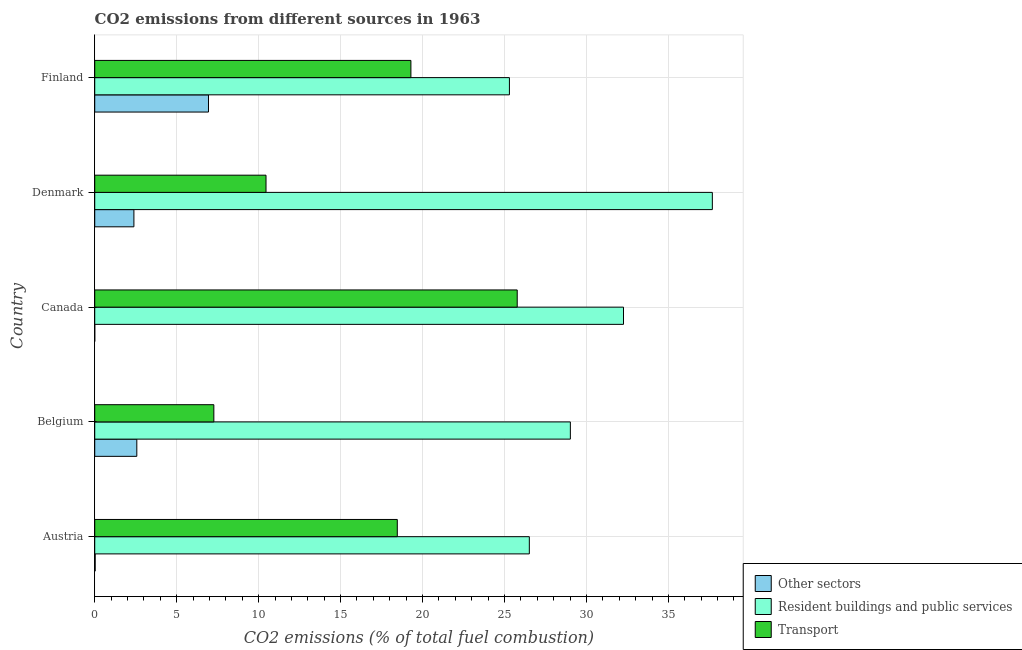How many different coloured bars are there?
Your response must be concise. 3. How many groups of bars are there?
Offer a very short reply. 5. Are the number of bars per tick equal to the number of legend labels?
Keep it short and to the point. No. Are the number of bars on each tick of the Y-axis equal?
Your answer should be very brief. No. How many bars are there on the 2nd tick from the top?
Your answer should be compact. 3. What is the label of the 2nd group of bars from the top?
Your answer should be very brief. Denmark. In how many cases, is the number of bars for a given country not equal to the number of legend labels?
Your answer should be very brief. 1. What is the percentage of co2 emissions from resident buildings and public services in Belgium?
Your response must be concise. 29.02. Across all countries, what is the maximum percentage of co2 emissions from resident buildings and public services?
Your answer should be compact. 37.68. What is the total percentage of co2 emissions from resident buildings and public services in the graph?
Provide a short and direct response. 150.78. What is the difference between the percentage of co2 emissions from resident buildings and public services in Austria and that in Belgium?
Provide a short and direct response. -2.5. What is the difference between the percentage of co2 emissions from resident buildings and public services in Finland and the percentage of co2 emissions from transport in Canada?
Your answer should be very brief. -0.48. What is the average percentage of co2 emissions from transport per country?
Provide a succinct answer. 16.25. What is the difference between the percentage of co2 emissions from other sectors and percentage of co2 emissions from resident buildings and public services in Denmark?
Offer a very short reply. -35.29. What is the ratio of the percentage of co2 emissions from resident buildings and public services in Canada to that in Finland?
Make the answer very short. 1.27. What is the difference between the highest and the second highest percentage of co2 emissions from resident buildings and public services?
Keep it short and to the point. 5.42. What is the difference between the highest and the lowest percentage of co2 emissions from transport?
Give a very brief answer. 18.51. How many bars are there?
Make the answer very short. 14. Are all the bars in the graph horizontal?
Give a very brief answer. Yes. How many countries are there in the graph?
Provide a succinct answer. 5. What is the title of the graph?
Offer a very short reply. CO2 emissions from different sources in 1963. What is the label or title of the X-axis?
Ensure brevity in your answer.  CO2 emissions (% of total fuel combustion). What is the CO2 emissions (% of total fuel combustion) of Other sectors in Austria?
Keep it short and to the point. 0.03. What is the CO2 emissions (% of total fuel combustion) of Resident buildings and public services in Austria?
Provide a succinct answer. 26.52. What is the CO2 emissions (% of total fuel combustion) in Transport in Austria?
Offer a very short reply. 18.46. What is the CO2 emissions (% of total fuel combustion) of Other sectors in Belgium?
Provide a short and direct response. 2.57. What is the CO2 emissions (% of total fuel combustion) in Resident buildings and public services in Belgium?
Provide a short and direct response. 29.02. What is the CO2 emissions (% of total fuel combustion) of Transport in Belgium?
Give a very brief answer. 7.27. What is the CO2 emissions (% of total fuel combustion) in Resident buildings and public services in Canada?
Your response must be concise. 32.26. What is the CO2 emissions (% of total fuel combustion) of Transport in Canada?
Offer a terse response. 25.78. What is the CO2 emissions (% of total fuel combustion) in Other sectors in Denmark?
Make the answer very short. 2.39. What is the CO2 emissions (% of total fuel combustion) in Resident buildings and public services in Denmark?
Keep it short and to the point. 37.68. What is the CO2 emissions (% of total fuel combustion) in Transport in Denmark?
Your answer should be very brief. 10.45. What is the CO2 emissions (% of total fuel combustion) of Other sectors in Finland?
Provide a short and direct response. 6.94. What is the CO2 emissions (% of total fuel combustion) of Resident buildings and public services in Finland?
Ensure brevity in your answer.  25.3. What is the CO2 emissions (% of total fuel combustion) of Transport in Finland?
Provide a succinct answer. 19.29. Across all countries, what is the maximum CO2 emissions (% of total fuel combustion) of Other sectors?
Provide a short and direct response. 6.94. Across all countries, what is the maximum CO2 emissions (% of total fuel combustion) of Resident buildings and public services?
Provide a succinct answer. 37.68. Across all countries, what is the maximum CO2 emissions (% of total fuel combustion) in Transport?
Offer a very short reply. 25.78. Across all countries, what is the minimum CO2 emissions (% of total fuel combustion) in Resident buildings and public services?
Give a very brief answer. 25.3. Across all countries, what is the minimum CO2 emissions (% of total fuel combustion) in Transport?
Give a very brief answer. 7.27. What is the total CO2 emissions (% of total fuel combustion) of Other sectors in the graph?
Offer a terse response. 11.92. What is the total CO2 emissions (% of total fuel combustion) of Resident buildings and public services in the graph?
Offer a terse response. 150.78. What is the total CO2 emissions (% of total fuel combustion) of Transport in the graph?
Provide a short and direct response. 81.24. What is the difference between the CO2 emissions (% of total fuel combustion) in Other sectors in Austria and that in Belgium?
Make the answer very short. -2.54. What is the difference between the CO2 emissions (% of total fuel combustion) of Resident buildings and public services in Austria and that in Belgium?
Provide a succinct answer. -2.5. What is the difference between the CO2 emissions (% of total fuel combustion) in Transport in Austria and that in Belgium?
Give a very brief answer. 11.19. What is the difference between the CO2 emissions (% of total fuel combustion) of Resident buildings and public services in Austria and that in Canada?
Ensure brevity in your answer.  -5.74. What is the difference between the CO2 emissions (% of total fuel combustion) in Transport in Austria and that in Canada?
Give a very brief answer. -7.32. What is the difference between the CO2 emissions (% of total fuel combustion) in Other sectors in Austria and that in Denmark?
Offer a terse response. -2.36. What is the difference between the CO2 emissions (% of total fuel combustion) of Resident buildings and public services in Austria and that in Denmark?
Offer a very short reply. -11.17. What is the difference between the CO2 emissions (% of total fuel combustion) of Transport in Austria and that in Denmark?
Offer a terse response. 8.01. What is the difference between the CO2 emissions (% of total fuel combustion) in Other sectors in Austria and that in Finland?
Give a very brief answer. -6.91. What is the difference between the CO2 emissions (% of total fuel combustion) in Resident buildings and public services in Austria and that in Finland?
Your answer should be compact. 1.22. What is the difference between the CO2 emissions (% of total fuel combustion) of Transport in Austria and that in Finland?
Keep it short and to the point. -0.83. What is the difference between the CO2 emissions (% of total fuel combustion) in Resident buildings and public services in Belgium and that in Canada?
Give a very brief answer. -3.24. What is the difference between the CO2 emissions (% of total fuel combustion) of Transport in Belgium and that in Canada?
Offer a terse response. -18.51. What is the difference between the CO2 emissions (% of total fuel combustion) of Other sectors in Belgium and that in Denmark?
Your answer should be very brief. 0.18. What is the difference between the CO2 emissions (% of total fuel combustion) of Resident buildings and public services in Belgium and that in Denmark?
Your answer should be very brief. -8.66. What is the difference between the CO2 emissions (% of total fuel combustion) of Transport in Belgium and that in Denmark?
Provide a short and direct response. -3.18. What is the difference between the CO2 emissions (% of total fuel combustion) in Other sectors in Belgium and that in Finland?
Your response must be concise. -4.37. What is the difference between the CO2 emissions (% of total fuel combustion) of Resident buildings and public services in Belgium and that in Finland?
Make the answer very short. 3.72. What is the difference between the CO2 emissions (% of total fuel combustion) in Transport in Belgium and that in Finland?
Offer a very short reply. -12.02. What is the difference between the CO2 emissions (% of total fuel combustion) of Resident buildings and public services in Canada and that in Denmark?
Your response must be concise. -5.42. What is the difference between the CO2 emissions (% of total fuel combustion) in Transport in Canada and that in Denmark?
Make the answer very short. 15.33. What is the difference between the CO2 emissions (% of total fuel combustion) of Resident buildings and public services in Canada and that in Finland?
Offer a terse response. 6.96. What is the difference between the CO2 emissions (% of total fuel combustion) in Transport in Canada and that in Finland?
Your answer should be compact. 6.49. What is the difference between the CO2 emissions (% of total fuel combustion) of Other sectors in Denmark and that in Finland?
Your answer should be very brief. -4.55. What is the difference between the CO2 emissions (% of total fuel combustion) in Resident buildings and public services in Denmark and that in Finland?
Your answer should be compact. 12.38. What is the difference between the CO2 emissions (% of total fuel combustion) of Transport in Denmark and that in Finland?
Ensure brevity in your answer.  -8.84. What is the difference between the CO2 emissions (% of total fuel combustion) in Other sectors in Austria and the CO2 emissions (% of total fuel combustion) in Resident buildings and public services in Belgium?
Offer a very short reply. -28.99. What is the difference between the CO2 emissions (% of total fuel combustion) of Other sectors in Austria and the CO2 emissions (% of total fuel combustion) of Transport in Belgium?
Provide a succinct answer. -7.24. What is the difference between the CO2 emissions (% of total fuel combustion) of Resident buildings and public services in Austria and the CO2 emissions (% of total fuel combustion) of Transport in Belgium?
Offer a terse response. 19.25. What is the difference between the CO2 emissions (% of total fuel combustion) in Other sectors in Austria and the CO2 emissions (% of total fuel combustion) in Resident buildings and public services in Canada?
Ensure brevity in your answer.  -32.23. What is the difference between the CO2 emissions (% of total fuel combustion) in Other sectors in Austria and the CO2 emissions (% of total fuel combustion) in Transport in Canada?
Provide a succinct answer. -25.75. What is the difference between the CO2 emissions (% of total fuel combustion) of Resident buildings and public services in Austria and the CO2 emissions (% of total fuel combustion) of Transport in Canada?
Your answer should be compact. 0.74. What is the difference between the CO2 emissions (% of total fuel combustion) in Other sectors in Austria and the CO2 emissions (% of total fuel combustion) in Resident buildings and public services in Denmark?
Offer a terse response. -37.65. What is the difference between the CO2 emissions (% of total fuel combustion) in Other sectors in Austria and the CO2 emissions (% of total fuel combustion) in Transport in Denmark?
Provide a succinct answer. -10.42. What is the difference between the CO2 emissions (% of total fuel combustion) of Resident buildings and public services in Austria and the CO2 emissions (% of total fuel combustion) of Transport in Denmark?
Your answer should be very brief. 16.07. What is the difference between the CO2 emissions (% of total fuel combustion) in Other sectors in Austria and the CO2 emissions (% of total fuel combustion) in Resident buildings and public services in Finland?
Your answer should be compact. -25.27. What is the difference between the CO2 emissions (% of total fuel combustion) in Other sectors in Austria and the CO2 emissions (% of total fuel combustion) in Transport in Finland?
Offer a terse response. -19.26. What is the difference between the CO2 emissions (% of total fuel combustion) of Resident buildings and public services in Austria and the CO2 emissions (% of total fuel combustion) of Transport in Finland?
Make the answer very short. 7.23. What is the difference between the CO2 emissions (% of total fuel combustion) in Other sectors in Belgium and the CO2 emissions (% of total fuel combustion) in Resident buildings and public services in Canada?
Keep it short and to the point. -29.69. What is the difference between the CO2 emissions (% of total fuel combustion) in Other sectors in Belgium and the CO2 emissions (% of total fuel combustion) in Transport in Canada?
Provide a short and direct response. -23.21. What is the difference between the CO2 emissions (% of total fuel combustion) in Resident buildings and public services in Belgium and the CO2 emissions (% of total fuel combustion) in Transport in Canada?
Offer a very short reply. 3.24. What is the difference between the CO2 emissions (% of total fuel combustion) of Other sectors in Belgium and the CO2 emissions (% of total fuel combustion) of Resident buildings and public services in Denmark?
Keep it short and to the point. -35.11. What is the difference between the CO2 emissions (% of total fuel combustion) in Other sectors in Belgium and the CO2 emissions (% of total fuel combustion) in Transport in Denmark?
Offer a terse response. -7.88. What is the difference between the CO2 emissions (% of total fuel combustion) in Resident buildings and public services in Belgium and the CO2 emissions (% of total fuel combustion) in Transport in Denmark?
Provide a short and direct response. 18.57. What is the difference between the CO2 emissions (% of total fuel combustion) in Other sectors in Belgium and the CO2 emissions (% of total fuel combustion) in Resident buildings and public services in Finland?
Your response must be concise. -22.73. What is the difference between the CO2 emissions (% of total fuel combustion) of Other sectors in Belgium and the CO2 emissions (% of total fuel combustion) of Transport in Finland?
Give a very brief answer. -16.72. What is the difference between the CO2 emissions (% of total fuel combustion) in Resident buildings and public services in Belgium and the CO2 emissions (% of total fuel combustion) in Transport in Finland?
Your answer should be very brief. 9.73. What is the difference between the CO2 emissions (% of total fuel combustion) in Resident buildings and public services in Canada and the CO2 emissions (% of total fuel combustion) in Transport in Denmark?
Provide a short and direct response. 21.81. What is the difference between the CO2 emissions (% of total fuel combustion) in Resident buildings and public services in Canada and the CO2 emissions (% of total fuel combustion) in Transport in Finland?
Offer a very short reply. 12.97. What is the difference between the CO2 emissions (% of total fuel combustion) of Other sectors in Denmark and the CO2 emissions (% of total fuel combustion) of Resident buildings and public services in Finland?
Your answer should be very brief. -22.91. What is the difference between the CO2 emissions (% of total fuel combustion) of Other sectors in Denmark and the CO2 emissions (% of total fuel combustion) of Transport in Finland?
Offer a terse response. -16.9. What is the difference between the CO2 emissions (% of total fuel combustion) in Resident buildings and public services in Denmark and the CO2 emissions (% of total fuel combustion) in Transport in Finland?
Make the answer very short. 18.39. What is the average CO2 emissions (% of total fuel combustion) of Other sectors per country?
Ensure brevity in your answer.  2.38. What is the average CO2 emissions (% of total fuel combustion) in Resident buildings and public services per country?
Provide a short and direct response. 30.16. What is the average CO2 emissions (% of total fuel combustion) in Transport per country?
Your response must be concise. 16.25. What is the difference between the CO2 emissions (% of total fuel combustion) in Other sectors and CO2 emissions (% of total fuel combustion) in Resident buildings and public services in Austria?
Give a very brief answer. -26.49. What is the difference between the CO2 emissions (% of total fuel combustion) of Other sectors and CO2 emissions (% of total fuel combustion) of Transport in Austria?
Offer a very short reply. -18.43. What is the difference between the CO2 emissions (% of total fuel combustion) in Resident buildings and public services and CO2 emissions (% of total fuel combustion) in Transport in Austria?
Make the answer very short. 8.06. What is the difference between the CO2 emissions (% of total fuel combustion) in Other sectors and CO2 emissions (% of total fuel combustion) in Resident buildings and public services in Belgium?
Provide a succinct answer. -26.45. What is the difference between the CO2 emissions (% of total fuel combustion) of Other sectors and CO2 emissions (% of total fuel combustion) of Transport in Belgium?
Your answer should be compact. -4.7. What is the difference between the CO2 emissions (% of total fuel combustion) in Resident buildings and public services and CO2 emissions (% of total fuel combustion) in Transport in Belgium?
Offer a very short reply. 21.75. What is the difference between the CO2 emissions (% of total fuel combustion) of Resident buildings and public services and CO2 emissions (% of total fuel combustion) of Transport in Canada?
Offer a very short reply. 6.48. What is the difference between the CO2 emissions (% of total fuel combustion) of Other sectors and CO2 emissions (% of total fuel combustion) of Resident buildings and public services in Denmark?
Keep it short and to the point. -35.29. What is the difference between the CO2 emissions (% of total fuel combustion) of Other sectors and CO2 emissions (% of total fuel combustion) of Transport in Denmark?
Keep it short and to the point. -8.06. What is the difference between the CO2 emissions (% of total fuel combustion) of Resident buildings and public services and CO2 emissions (% of total fuel combustion) of Transport in Denmark?
Provide a short and direct response. 27.23. What is the difference between the CO2 emissions (% of total fuel combustion) of Other sectors and CO2 emissions (% of total fuel combustion) of Resident buildings and public services in Finland?
Offer a very short reply. -18.36. What is the difference between the CO2 emissions (% of total fuel combustion) in Other sectors and CO2 emissions (% of total fuel combustion) in Transport in Finland?
Offer a terse response. -12.35. What is the difference between the CO2 emissions (% of total fuel combustion) of Resident buildings and public services and CO2 emissions (% of total fuel combustion) of Transport in Finland?
Give a very brief answer. 6.01. What is the ratio of the CO2 emissions (% of total fuel combustion) in Other sectors in Austria to that in Belgium?
Your response must be concise. 0.01. What is the ratio of the CO2 emissions (% of total fuel combustion) in Resident buildings and public services in Austria to that in Belgium?
Your answer should be compact. 0.91. What is the ratio of the CO2 emissions (% of total fuel combustion) in Transport in Austria to that in Belgium?
Your answer should be very brief. 2.54. What is the ratio of the CO2 emissions (% of total fuel combustion) in Resident buildings and public services in Austria to that in Canada?
Your response must be concise. 0.82. What is the ratio of the CO2 emissions (% of total fuel combustion) in Transport in Austria to that in Canada?
Provide a succinct answer. 0.72. What is the ratio of the CO2 emissions (% of total fuel combustion) of Other sectors in Austria to that in Denmark?
Make the answer very short. 0.01. What is the ratio of the CO2 emissions (% of total fuel combustion) of Resident buildings and public services in Austria to that in Denmark?
Ensure brevity in your answer.  0.7. What is the ratio of the CO2 emissions (% of total fuel combustion) of Transport in Austria to that in Denmark?
Offer a terse response. 1.77. What is the ratio of the CO2 emissions (% of total fuel combustion) in Other sectors in Austria to that in Finland?
Give a very brief answer. 0. What is the ratio of the CO2 emissions (% of total fuel combustion) in Resident buildings and public services in Austria to that in Finland?
Your answer should be very brief. 1.05. What is the ratio of the CO2 emissions (% of total fuel combustion) in Transport in Austria to that in Finland?
Ensure brevity in your answer.  0.96. What is the ratio of the CO2 emissions (% of total fuel combustion) of Resident buildings and public services in Belgium to that in Canada?
Give a very brief answer. 0.9. What is the ratio of the CO2 emissions (% of total fuel combustion) in Transport in Belgium to that in Canada?
Keep it short and to the point. 0.28. What is the ratio of the CO2 emissions (% of total fuel combustion) in Other sectors in Belgium to that in Denmark?
Provide a short and direct response. 1.07. What is the ratio of the CO2 emissions (% of total fuel combustion) of Resident buildings and public services in Belgium to that in Denmark?
Offer a very short reply. 0.77. What is the ratio of the CO2 emissions (% of total fuel combustion) in Transport in Belgium to that in Denmark?
Ensure brevity in your answer.  0.7. What is the ratio of the CO2 emissions (% of total fuel combustion) in Other sectors in Belgium to that in Finland?
Your answer should be very brief. 0.37. What is the ratio of the CO2 emissions (% of total fuel combustion) of Resident buildings and public services in Belgium to that in Finland?
Provide a succinct answer. 1.15. What is the ratio of the CO2 emissions (% of total fuel combustion) in Transport in Belgium to that in Finland?
Your answer should be compact. 0.38. What is the ratio of the CO2 emissions (% of total fuel combustion) in Resident buildings and public services in Canada to that in Denmark?
Your answer should be compact. 0.86. What is the ratio of the CO2 emissions (% of total fuel combustion) in Transport in Canada to that in Denmark?
Ensure brevity in your answer.  2.47. What is the ratio of the CO2 emissions (% of total fuel combustion) of Resident buildings and public services in Canada to that in Finland?
Keep it short and to the point. 1.28. What is the ratio of the CO2 emissions (% of total fuel combustion) in Transport in Canada to that in Finland?
Your answer should be compact. 1.34. What is the ratio of the CO2 emissions (% of total fuel combustion) in Other sectors in Denmark to that in Finland?
Your response must be concise. 0.34. What is the ratio of the CO2 emissions (% of total fuel combustion) in Resident buildings and public services in Denmark to that in Finland?
Your response must be concise. 1.49. What is the ratio of the CO2 emissions (% of total fuel combustion) in Transport in Denmark to that in Finland?
Make the answer very short. 0.54. What is the difference between the highest and the second highest CO2 emissions (% of total fuel combustion) of Other sectors?
Provide a succinct answer. 4.37. What is the difference between the highest and the second highest CO2 emissions (% of total fuel combustion) of Resident buildings and public services?
Your answer should be compact. 5.42. What is the difference between the highest and the second highest CO2 emissions (% of total fuel combustion) of Transport?
Give a very brief answer. 6.49. What is the difference between the highest and the lowest CO2 emissions (% of total fuel combustion) in Other sectors?
Give a very brief answer. 6.94. What is the difference between the highest and the lowest CO2 emissions (% of total fuel combustion) of Resident buildings and public services?
Ensure brevity in your answer.  12.38. What is the difference between the highest and the lowest CO2 emissions (% of total fuel combustion) in Transport?
Provide a short and direct response. 18.51. 